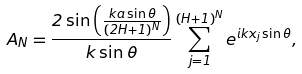<formula> <loc_0><loc_0><loc_500><loc_500>A _ { N } = \frac { 2 \sin \left ( \frac { k a \sin \theta } { ( 2 H + 1 ) ^ { N } } \right ) } { k \sin \theta } \sum _ { j = 1 } ^ { ( H + 1 ) ^ { N } } e ^ { i k x _ { j } \sin \theta } ,</formula> 